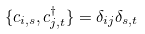Convert formula to latex. <formula><loc_0><loc_0><loc_500><loc_500>\{ c _ { i , s } , c ^ { \dagger } _ { j , t } \} = \delta _ { i j } \delta _ { s , t }</formula> 